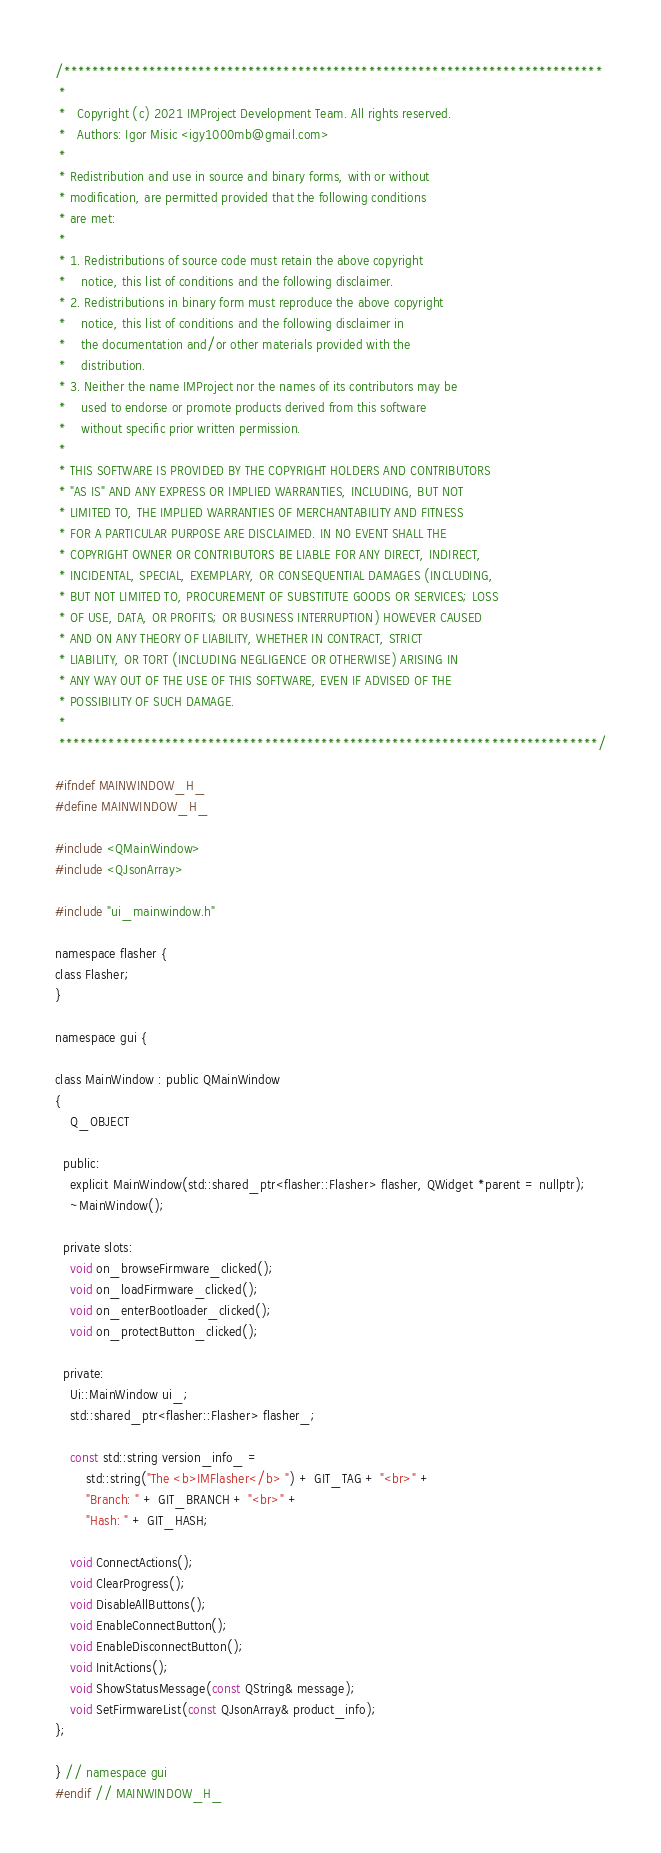<code> <loc_0><loc_0><loc_500><loc_500><_C_>/****************************************************************************
 *
 *   Copyright (c) 2021 IMProject Development Team. All rights reserved.
 *   Authors: Igor Misic <igy1000mb@gmail.com>
 *
 * Redistribution and use in source and binary forms, with or without
 * modification, are permitted provided that the following conditions
 * are met:
 *
 * 1. Redistributions of source code must retain the above copyright
 *    notice, this list of conditions and the following disclaimer.
 * 2. Redistributions in binary form must reproduce the above copyright
 *    notice, this list of conditions and the following disclaimer in
 *    the documentation and/or other materials provided with the
 *    distribution.
 * 3. Neither the name IMProject nor the names of its contributors may be
 *    used to endorse or promote products derived from this software
 *    without specific prior written permission.
 *
 * THIS SOFTWARE IS PROVIDED BY THE COPYRIGHT HOLDERS AND CONTRIBUTORS
 * "AS IS" AND ANY EXPRESS OR IMPLIED WARRANTIES, INCLUDING, BUT NOT
 * LIMITED TO, THE IMPLIED WARRANTIES OF MERCHANTABILITY AND FITNESS
 * FOR A PARTICULAR PURPOSE ARE DISCLAIMED. IN NO EVENT SHALL THE
 * COPYRIGHT OWNER OR CONTRIBUTORS BE LIABLE FOR ANY DIRECT, INDIRECT,
 * INCIDENTAL, SPECIAL, EXEMPLARY, OR CONSEQUENTIAL DAMAGES (INCLUDING,
 * BUT NOT LIMITED TO, PROCUREMENT OF SUBSTITUTE GOODS OR SERVICES; LOSS
 * OF USE, DATA, OR PROFITS; OR BUSINESS INTERRUPTION) HOWEVER CAUSED
 * AND ON ANY THEORY OF LIABILITY, WHETHER IN CONTRACT, STRICT
 * LIABILITY, OR TORT (INCLUDING NEGLIGENCE OR OTHERWISE) ARISING IN
 * ANY WAY OUT OF THE USE OF THIS SOFTWARE, EVEN IF ADVISED OF THE
 * POSSIBILITY OF SUCH DAMAGE.
 *
 ****************************************************************************/

#ifndef MAINWINDOW_H_
#define MAINWINDOW_H_

#include <QMainWindow>
#include <QJsonArray>

#include "ui_mainwindow.h"

namespace flasher {
class Flasher;
}

namespace gui {

class MainWindow : public QMainWindow
{
    Q_OBJECT

  public:
    explicit MainWindow(std::shared_ptr<flasher::Flasher> flasher, QWidget *parent = nullptr);
    ~MainWindow();

  private slots:
    void on_browseFirmware_clicked();
    void on_loadFirmware_clicked();
    void on_enterBootloader_clicked();
    void on_protectButton_clicked();

  private:
    Ui::MainWindow ui_;
    std::shared_ptr<flasher::Flasher> flasher_;

    const std::string version_info_ =
        std::string("The <b>IMFlasher</b> ") + GIT_TAG + "<br>" +
        "Branch: " + GIT_BRANCH + "<br>" +
        "Hash: " + GIT_HASH;

    void ConnectActions();
    void ClearProgress();
    void DisableAllButtons();
    void EnableConnectButton();
    void EnableDisconnectButton();
    void InitActions();
    void ShowStatusMessage(const QString& message);
    void SetFirmwareList(const QJsonArray& product_info);
};

} // namespace gui
#endif // MAINWINDOW_H_
</code> 